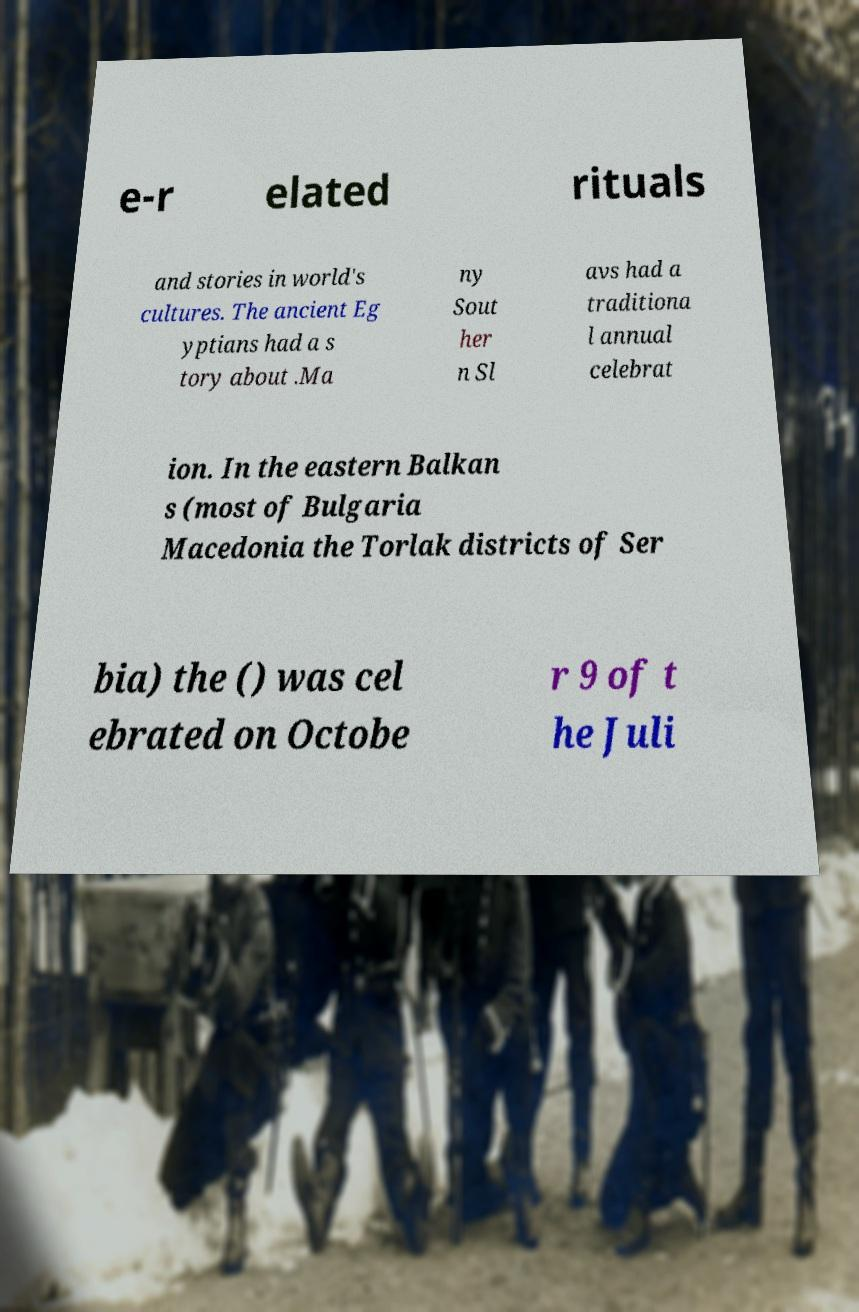For documentation purposes, I need the text within this image transcribed. Could you provide that? e-r elated rituals and stories in world's cultures. The ancient Eg yptians had a s tory about .Ma ny Sout her n Sl avs had a traditiona l annual celebrat ion. In the eastern Balkan s (most of Bulgaria Macedonia the Torlak districts of Ser bia) the () was cel ebrated on Octobe r 9 of t he Juli 